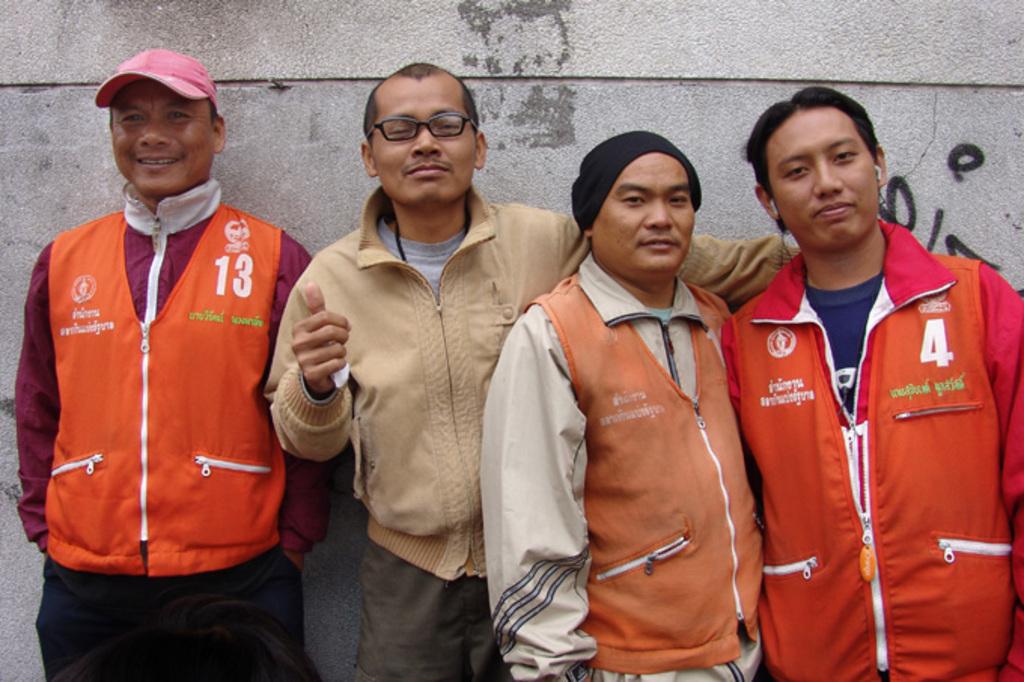What number is the person on the right?
Your answer should be very brief. 4. 